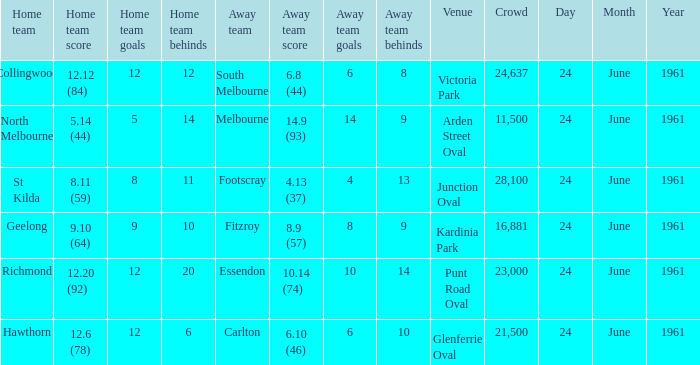What is the date of the game where the home team scored 9.10 (64)? 24 June 1961. 